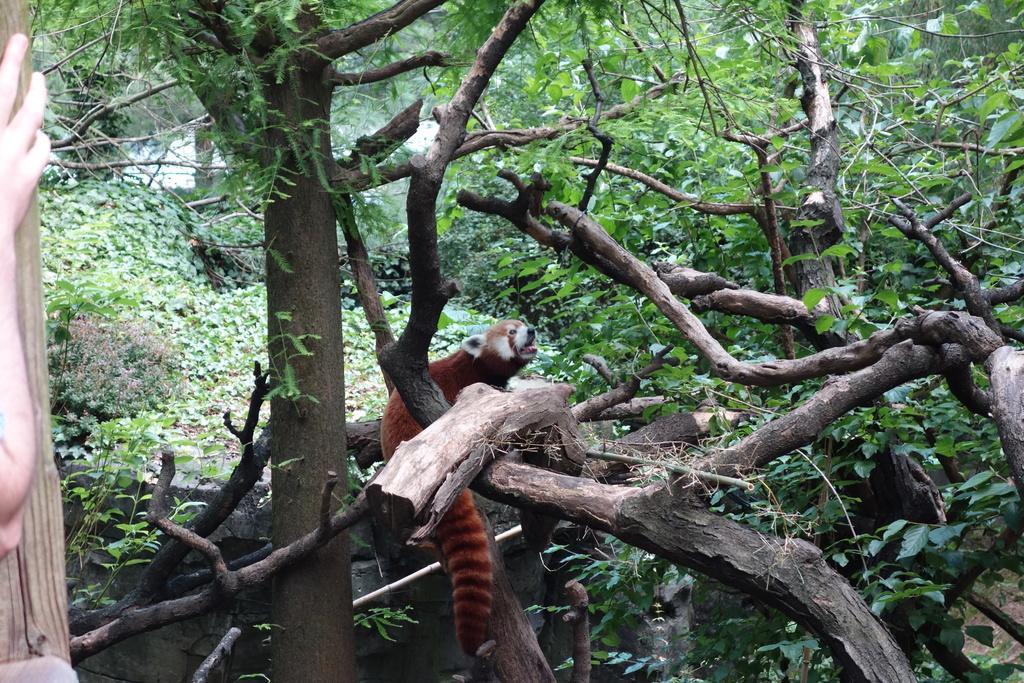In one or two sentences, can you explain what this image depicts? In this image, we can see some trees and plants. There is an animal in the middle of the image. There is a person hand on the left side of the image. 